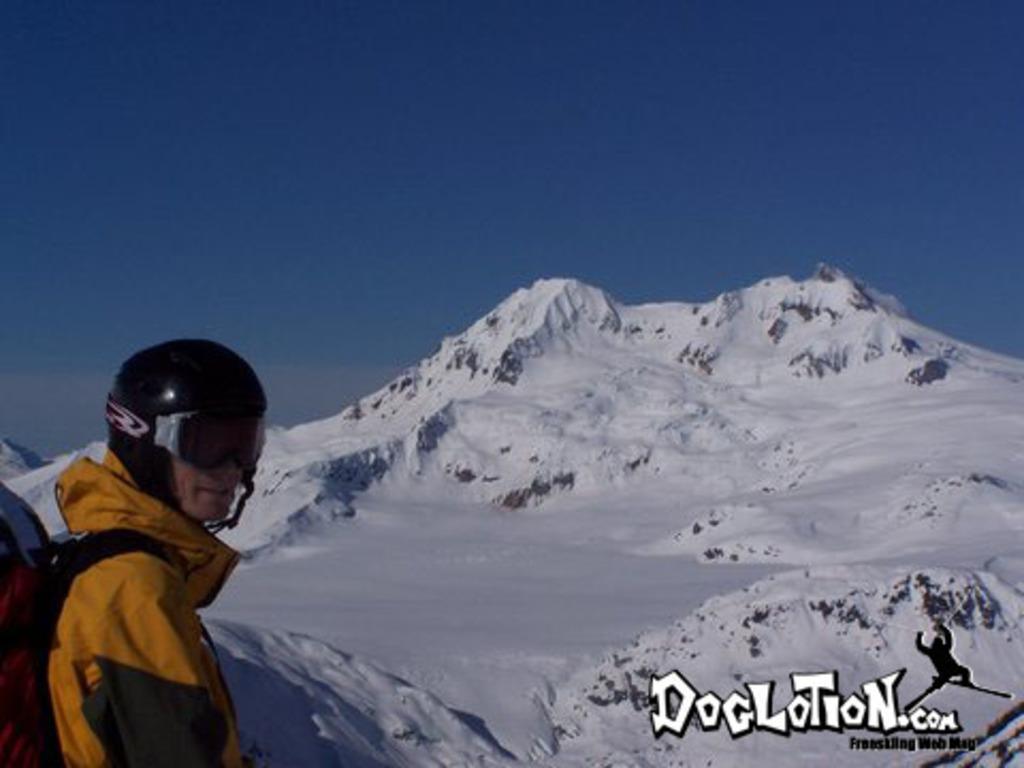In one or two sentences, can you explain what this image depicts? In this picture we can see a person in the front, this person wore goggles and a helmet, in the background we can see snow, at the right bottom there is some text, this person is carrying a backpack, we can see the sky at the top of the picture. 